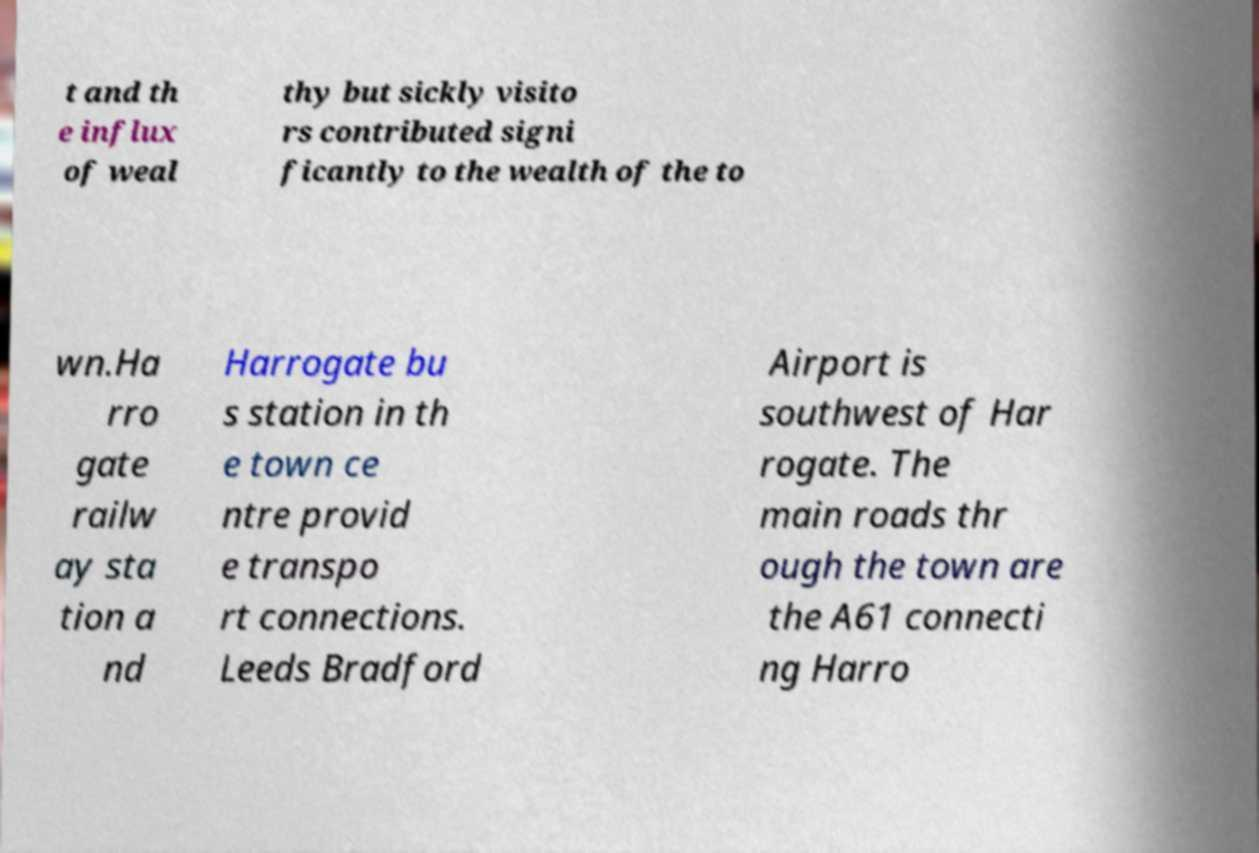Could you extract and type out the text from this image? t and th e influx of weal thy but sickly visito rs contributed signi ficantly to the wealth of the to wn.Ha rro gate railw ay sta tion a nd Harrogate bu s station in th e town ce ntre provid e transpo rt connections. Leeds Bradford Airport is southwest of Har rogate. The main roads thr ough the town are the A61 connecti ng Harro 